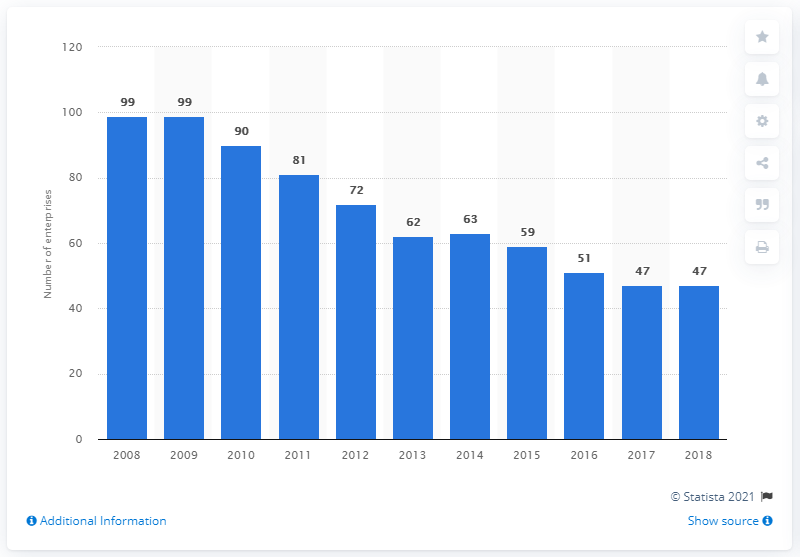Specify some key components in this picture. There were 47 enterprises in the manufacture of soft drinks, production of mineral waters, and other bottled water industry in Croatia in 2018. 